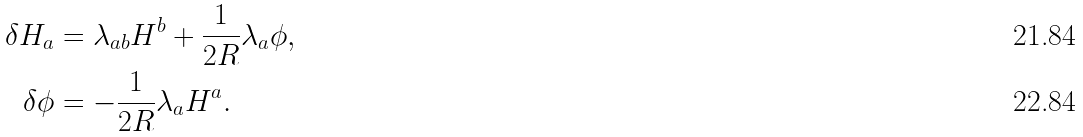<formula> <loc_0><loc_0><loc_500><loc_500>\delta H _ { a } & = \lambda _ { a b } H ^ { b } + \frac { 1 } { 2 R } \lambda _ { a } \phi , \\ \delta \phi & = - \frac { 1 } { 2 R } \lambda _ { a } H ^ { a } .</formula> 